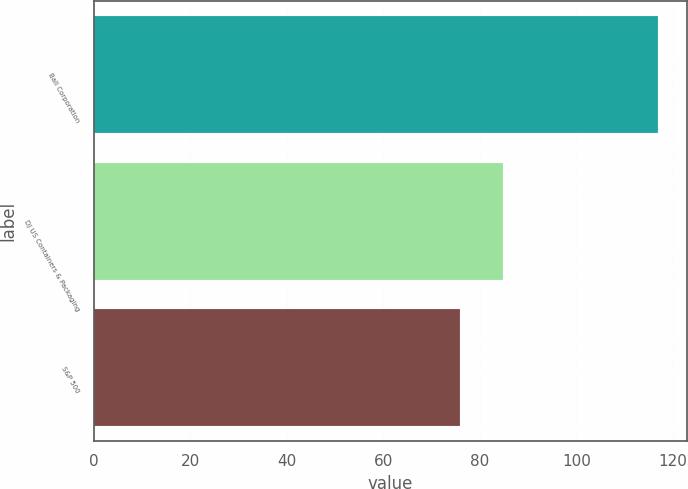Convert chart to OTSL. <chart><loc_0><loc_0><loc_500><loc_500><bar_chart><fcel>Ball Corporation<fcel>DJ US Containers & Packaging<fcel>S&P 500<nl><fcel>117.01<fcel>84.76<fcel>75.94<nl></chart> 